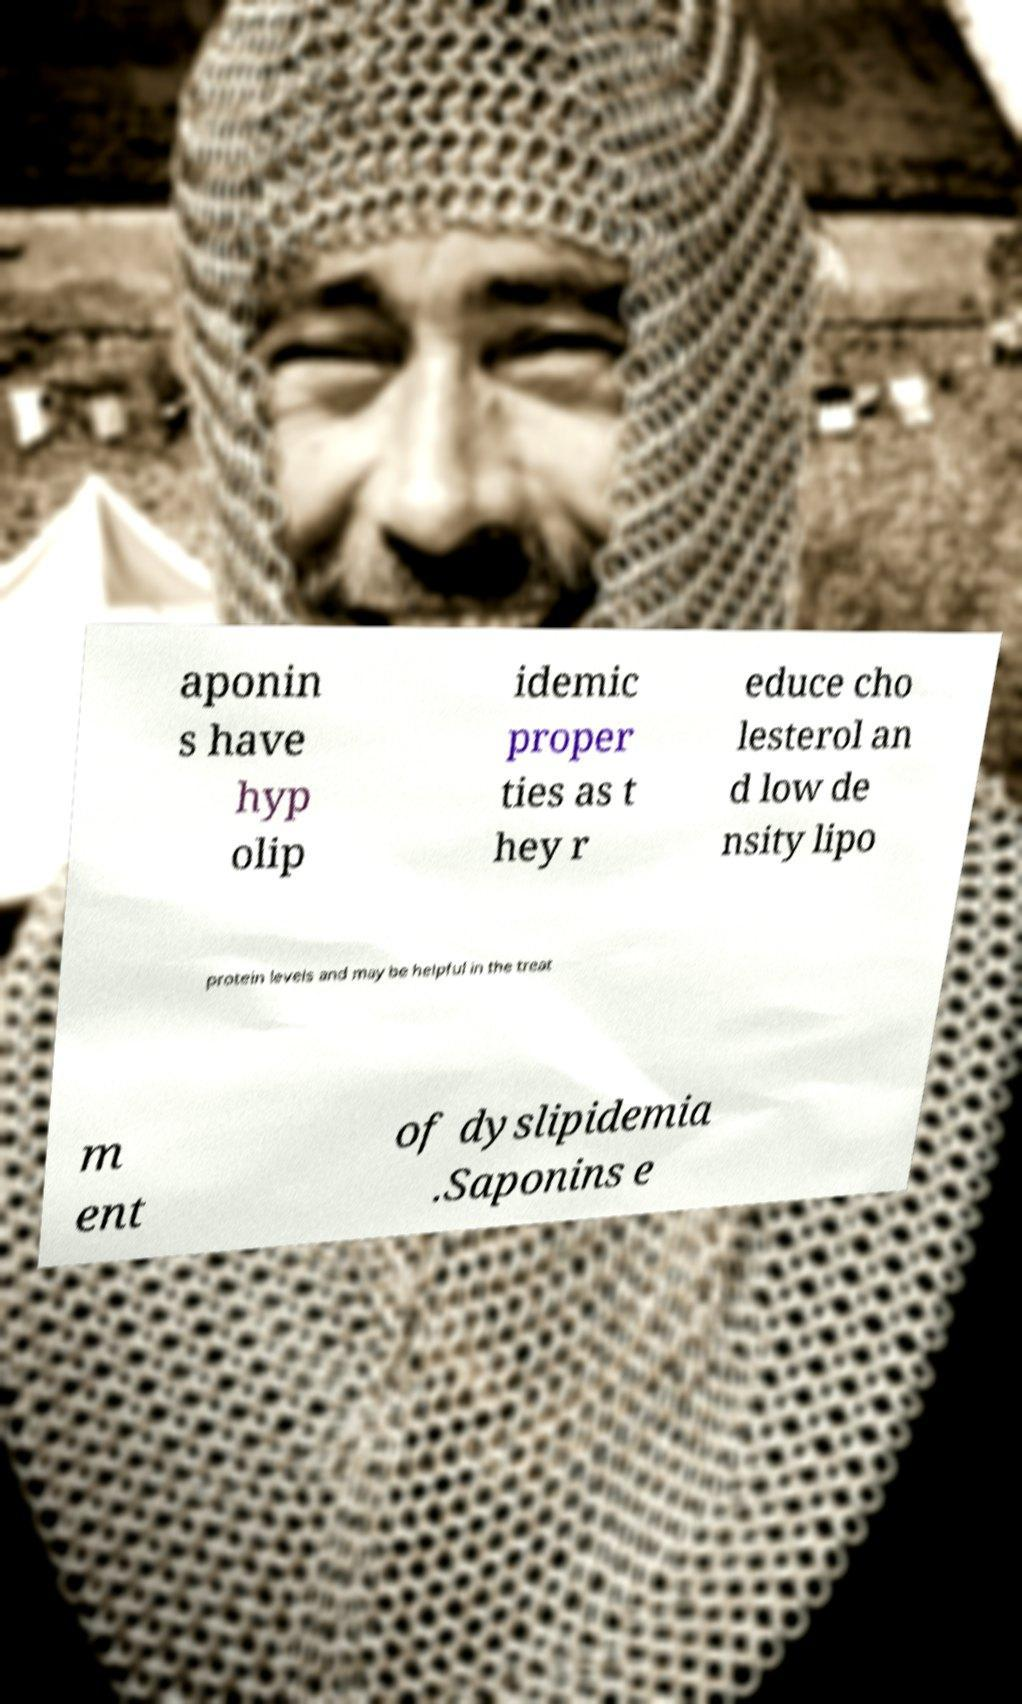Please read and relay the text visible in this image. What does it say? aponin s have hyp olip idemic proper ties as t hey r educe cho lesterol an d low de nsity lipo protein levels and may be helpful in the treat m ent of dyslipidemia .Saponins e 